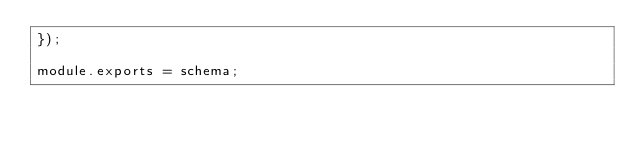<code> <loc_0><loc_0><loc_500><loc_500><_JavaScript_>});

module.exports = schema;
</code> 